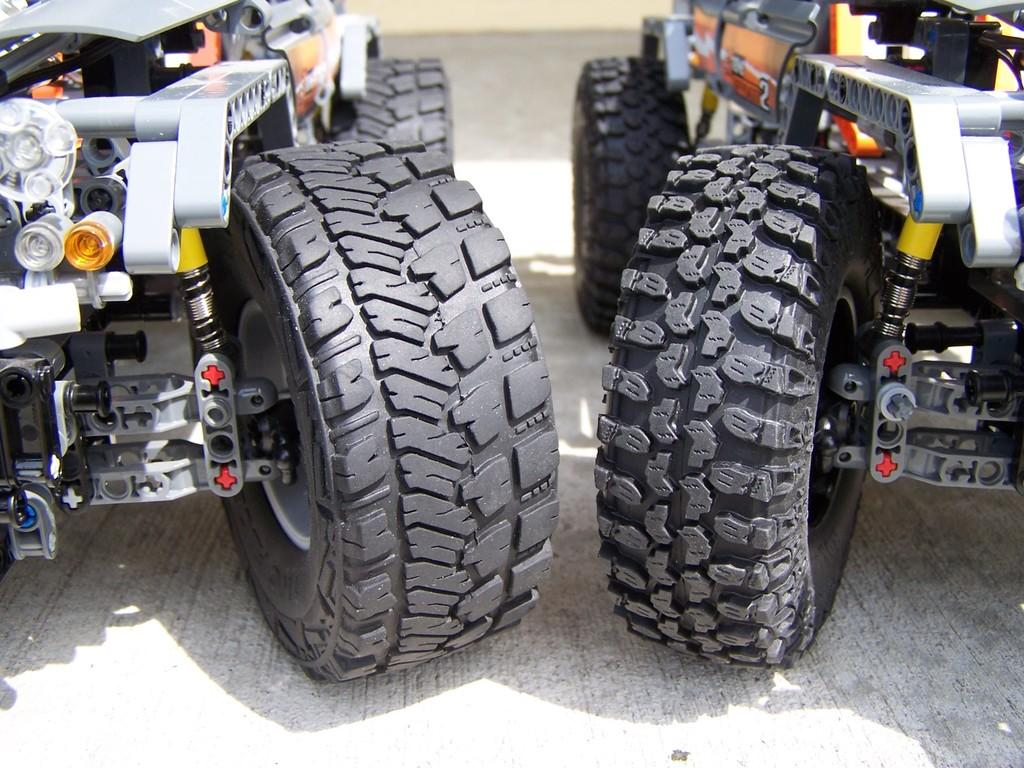What objects are present on the floor in the image? There are two toy cars on the floor in the image. Can you describe the toy cars in the image? The toy cars are the main objects visible on the floor. What type of cherry is being used as a toy car in the image? There is no cherry present in the image, and no cherry is being used as a toy car. 